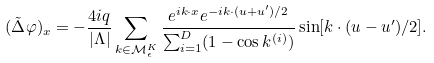Convert formula to latex. <formula><loc_0><loc_0><loc_500><loc_500>( \tilde { \Delta } \varphi ) _ { x } = - \frac { 4 i q } { | \Lambda | } \sum _ { k \in \mathcal { M } _ { \epsilon } ^ { K } } \frac { e ^ { i k \cdot x } e ^ { - i k \cdot ( u + u ^ { \prime } ) / 2 } } { \sum _ { i = 1 } ^ { D } ( 1 - \cos k ^ { ( i ) } ) } \sin [ k \cdot ( u - u ^ { \prime } ) / 2 ] .</formula> 